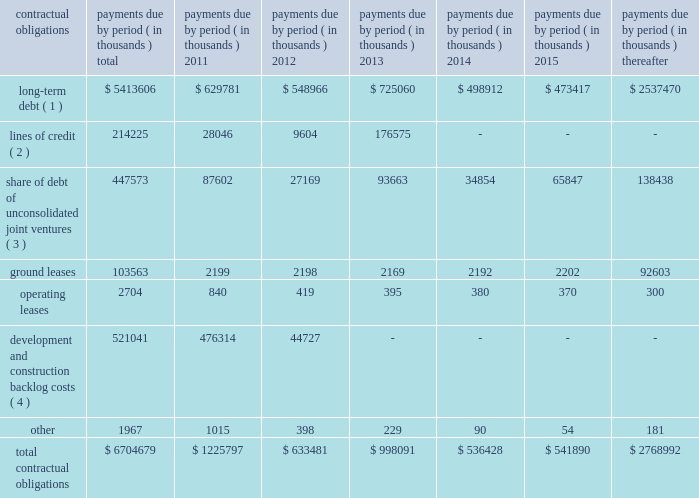39 annual report 2010 duke realty corporation | | related party transactions we provide property and asset management , leasing , construction and other tenant related services to unconsolidated companies in which we have equity interests .
For the years ended december 31 , 2010 , 2009 and 2008 , respectively , we earned management fees of $ 7.6 million , $ 8.4 million and $ 7.8 million , leasing fees of $ 2.7 million , $ 4.2 million and $ 2.8 million and construction and development fees of $ 10.3 million , $ 10.2 million and $ 12.7 million from these companies .
We recorded these fees based on contractual terms that approximate market rates for these types of services , and we have eliminated our ownership percentages of these fees in the consolidated financial statements .
Commitments and contingencies we have guaranteed the repayment of $ 95.4 million of economic development bonds issued by various municipalities in connection with certain commercial developments .
We will be required to make payments under our guarantees to the extent that incremental taxes from specified developments are not sufficient to pay the bond debt service .
Management does not believe that it is probable that we will be required to make any significant payments in satisfaction of these guarantees .
We also have guaranteed the repayment of secured and unsecured loans of six of our unconsolidated subsidiaries .
At december 31 , 2010 , the maximum guarantee exposure for these loans was approximately $ 245.4 million .
With the exception of the guarantee of the debt of 3630 peachtree joint venture , for which we recorded a contingent liability in 2009 of $ 36.3 million , management believes it probable that we will not be required to satisfy these guarantees .
We lease certain land positions with terms extending to december 2080 , with a total obligation of $ 103.6 million .
No payments on these ground leases are material in any individual year .
We are subject to various legal proceedings and claims that arise in the ordinary course of business .
In the opinion of management , the amount of any ultimate liability with respect to these actions will not materially affect our consolidated financial statements or results of operations .
Contractual obligations at december 31 , 2010 , we were subject to certain contractual payment obligations as described in the table below: .
( 1 ) our long-term debt consists of both secured and unsecured debt and includes both principal and interest .
Interest expense for variable rate debt was calculated using the interest rates as of december 31 , 2010 .
( 2 ) our unsecured lines of credit consist of an operating line of credit that matures february 2013 and the line of credit of a consolidated subsidiary that matures july 2011 .
Interest expense for our unsecured lines of credit was calculated using the most recent stated interest rates that were in effect .
( 3 ) our share of unconsolidated joint venture debt includes both principal and interest .
Interest expense for variable rate debt was calculated using the interest rate at december 31 , 2010 .
( 4 ) represents estimated remaining costs on the completion of owned development projects and third-party construction projects. .
What is the total long-term debt as a percentage of total contractual obligations? 
Computations: ((5413606 / 6704679) * 100)
Answer: 80.7437. 